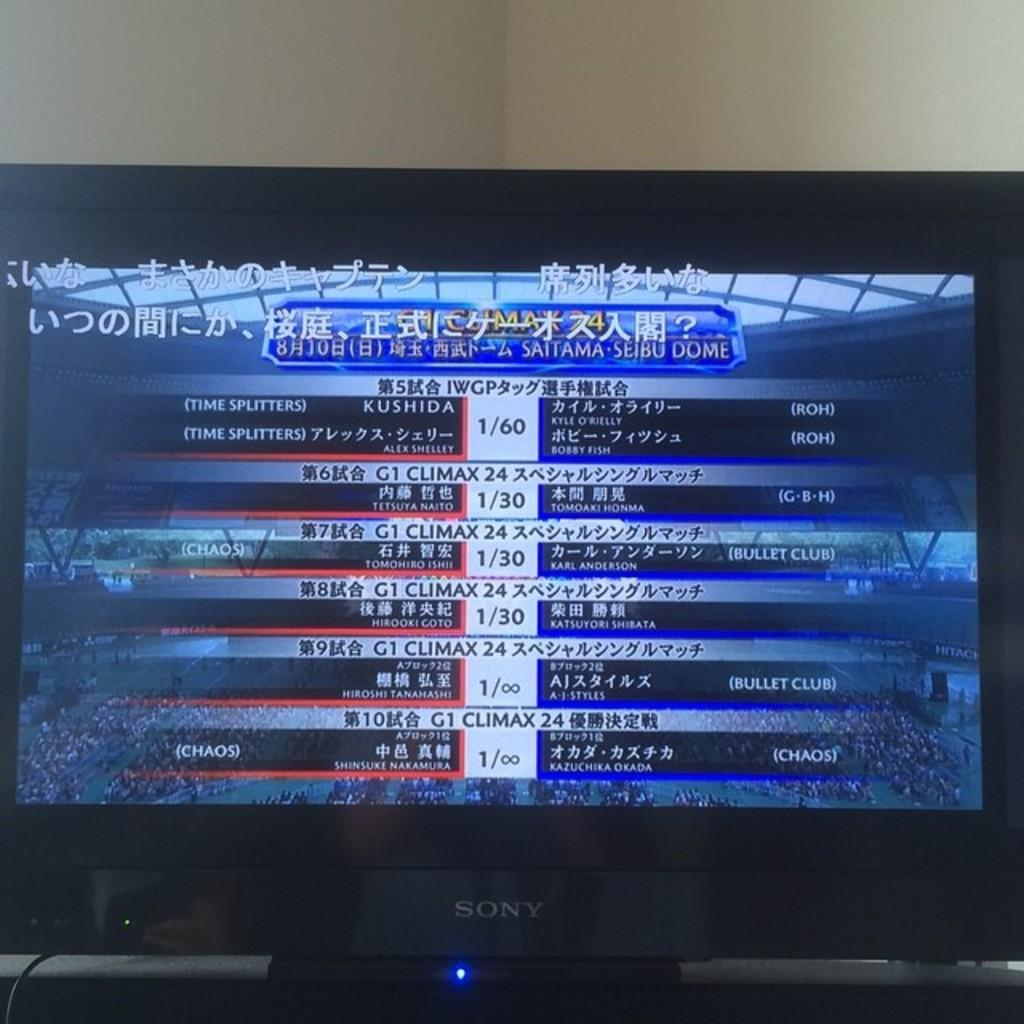Provide a one-sentence caption for the provided image. television showing sports team's scores names KUSHIDA and Chinese characters. 